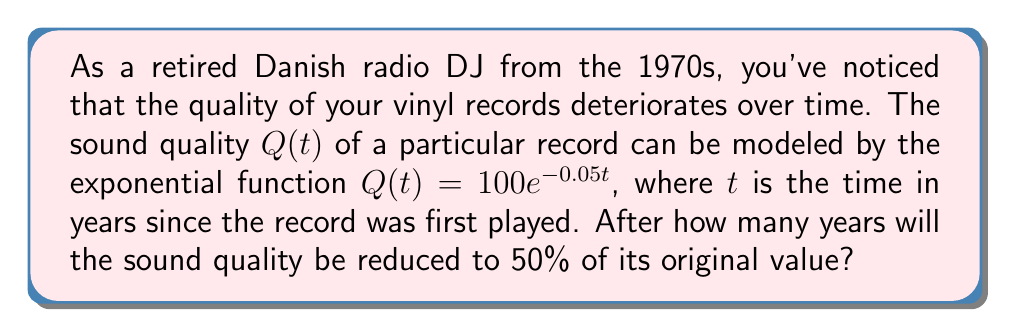Provide a solution to this math problem. Let's approach this step-by-step:

1) We start with the given function: $Q(t) = 100e^{-0.05t}$

2) We want to find when $Q(t)$ is equal to 50% of its original value. The original value (when $t=0$) is 100.

3) So, we need to solve the equation:
   $50 = 100e^{-0.05t}$

4) Divide both sides by 100:
   $0.5 = e^{-0.05t}$

5) Take the natural logarithm of both sides:
   $\ln(0.5) = \ln(e^{-0.05t})$

6) Simplify the right side using the properties of logarithms:
   $\ln(0.5) = -0.05t$

7) Solve for $t$:
   $t = \frac{\ln(0.5)}{-0.05}$

8) Calculate:
   $t = \frac{-0.693147...}{-0.05} \approx 13.86$ years

Therefore, it will take approximately 13.86 years for the sound quality to be reduced to 50% of its original value.
Answer: $13.86$ years 